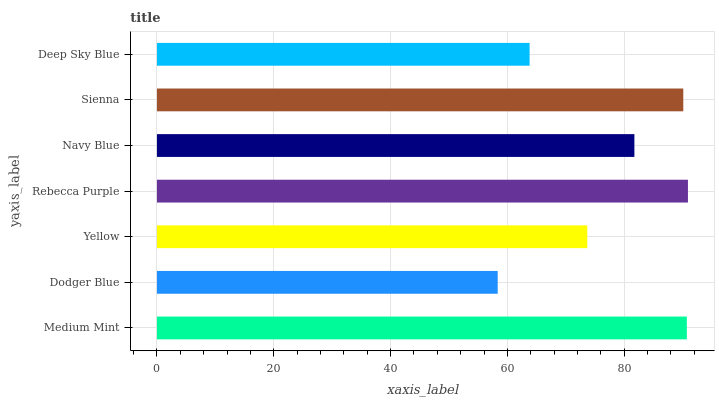Is Dodger Blue the minimum?
Answer yes or no. Yes. Is Rebecca Purple the maximum?
Answer yes or no. Yes. Is Yellow the minimum?
Answer yes or no. No. Is Yellow the maximum?
Answer yes or no. No. Is Yellow greater than Dodger Blue?
Answer yes or no. Yes. Is Dodger Blue less than Yellow?
Answer yes or no. Yes. Is Dodger Blue greater than Yellow?
Answer yes or no. No. Is Yellow less than Dodger Blue?
Answer yes or no. No. Is Navy Blue the high median?
Answer yes or no. Yes. Is Navy Blue the low median?
Answer yes or no. Yes. Is Medium Mint the high median?
Answer yes or no. No. Is Yellow the low median?
Answer yes or no. No. 